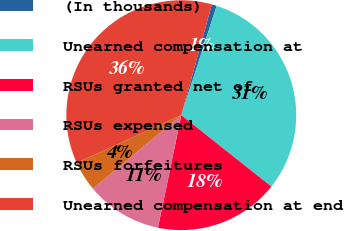<chart> <loc_0><loc_0><loc_500><loc_500><pie_chart><fcel>(In thousands)<fcel>Unearned compensation at<fcel>RSUs granted net of<fcel>RSUs expensed<fcel>RSUs forfeitures<fcel>Unearned compensation at end<nl><fcel>0.7%<fcel>30.68%<fcel>17.58%<fcel>10.7%<fcel>4.24%<fcel>36.09%<nl></chart> 